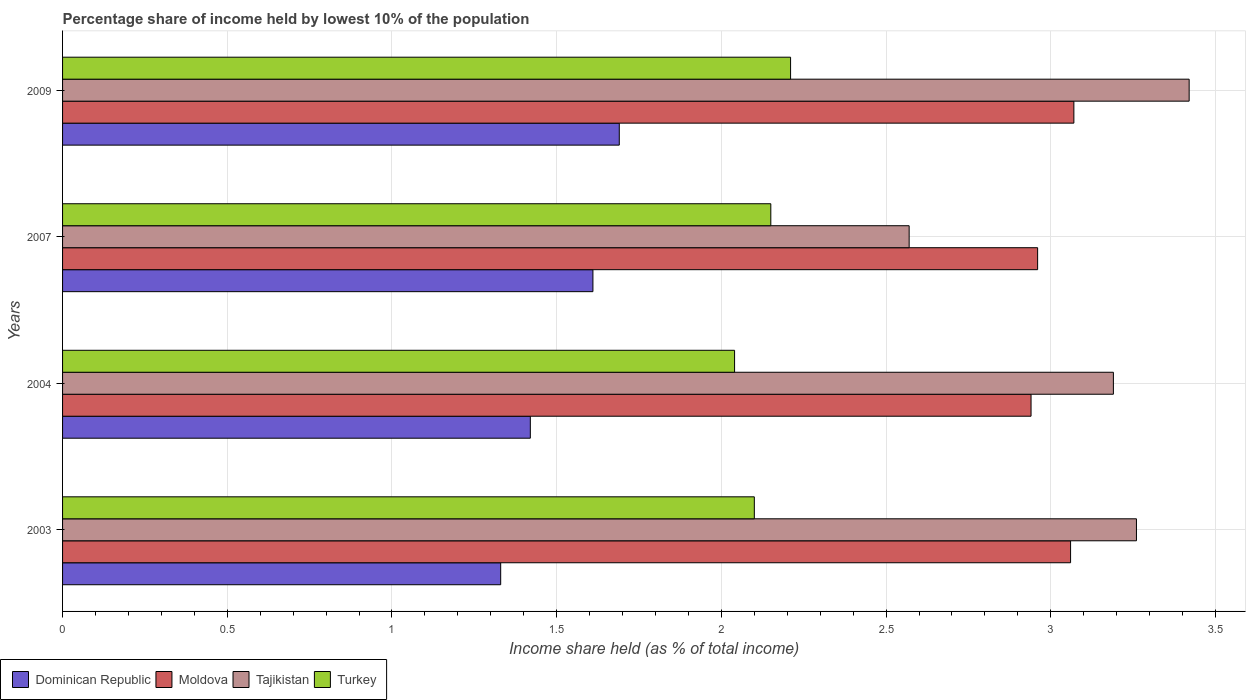Are the number of bars per tick equal to the number of legend labels?
Provide a short and direct response. Yes. How many bars are there on the 1st tick from the bottom?
Ensure brevity in your answer.  4. What is the label of the 2nd group of bars from the top?
Your answer should be compact. 2007. In how many cases, is the number of bars for a given year not equal to the number of legend labels?
Make the answer very short. 0. What is the percentage share of income held by lowest 10% of the population in Turkey in 2009?
Provide a succinct answer. 2.21. Across all years, what is the maximum percentage share of income held by lowest 10% of the population in Tajikistan?
Provide a succinct answer. 3.42. Across all years, what is the minimum percentage share of income held by lowest 10% of the population in Tajikistan?
Keep it short and to the point. 2.57. In which year was the percentage share of income held by lowest 10% of the population in Moldova maximum?
Provide a short and direct response. 2009. In which year was the percentage share of income held by lowest 10% of the population in Dominican Republic minimum?
Provide a succinct answer. 2003. What is the total percentage share of income held by lowest 10% of the population in Dominican Republic in the graph?
Provide a short and direct response. 6.05. What is the difference between the percentage share of income held by lowest 10% of the population in Tajikistan in 2004 and that in 2007?
Your answer should be compact. 0.62. What is the difference between the percentage share of income held by lowest 10% of the population in Moldova in 2009 and the percentage share of income held by lowest 10% of the population in Turkey in 2007?
Make the answer very short. 0.92. What is the average percentage share of income held by lowest 10% of the population in Turkey per year?
Provide a succinct answer. 2.12. In the year 2009, what is the difference between the percentage share of income held by lowest 10% of the population in Moldova and percentage share of income held by lowest 10% of the population in Tajikistan?
Your response must be concise. -0.35. What is the ratio of the percentage share of income held by lowest 10% of the population in Tajikistan in 2004 to that in 2007?
Offer a very short reply. 1.24. Is the percentage share of income held by lowest 10% of the population in Tajikistan in 2003 less than that in 2007?
Your answer should be very brief. No. Is the difference between the percentage share of income held by lowest 10% of the population in Moldova in 2004 and 2009 greater than the difference between the percentage share of income held by lowest 10% of the population in Tajikistan in 2004 and 2009?
Provide a succinct answer. Yes. What is the difference between the highest and the second highest percentage share of income held by lowest 10% of the population in Turkey?
Provide a succinct answer. 0.06. What is the difference between the highest and the lowest percentage share of income held by lowest 10% of the population in Turkey?
Ensure brevity in your answer.  0.17. In how many years, is the percentage share of income held by lowest 10% of the population in Dominican Republic greater than the average percentage share of income held by lowest 10% of the population in Dominican Republic taken over all years?
Your answer should be compact. 2. Is the sum of the percentage share of income held by lowest 10% of the population in Dominican Republic in 2004 and 2007 greater than the maximum percentage share of income held by lowest 10% of the population in Tajikistan across all years?
Make the answer very short. No. Is it the case that in every year, the sum of the percentage share of income held by lowest 10% of the population in Turkey and percentage share of income held by lowest 10% of the population in Moldova is greater than the sum of percentage share of income held by lowest 10% of the population in Dominican Republic and percentage share of income held by lowest 10% of the population in Tajikistan?
Keep it short and to the point. No. What does the 4th bar from the top in 2003 represents?
Offer a terse response. Dominican Republic. What does the 1st bar from the bottom in 2004 represents?
Ensure brevity in your answer.  Dominican Republic. Are all the bars in the graph horizontal?
Your answer should be very brief. Yes. How many years are there in the graph?
Provide a succinct answer. 4. Does the graph contain any zero values?
Your answer should be compact. No. Does the graph contain grids?
Your answer should be very brief. Yes. How are the legend labels stacked?
Your response must be concise. Horizontal. What is the title of the graph?
Make the answer very short. Percentage share of income held by lowest 10% of the population. Does "Ireland" appear as one of the legend labels in the graph?
Make the answer very short. No. What is the label or title of the X-axis?
Make the answer very short. Income share held (as % of total income). What is the Income share held (as % of total income) in Dominican Republic in 2003?
Your response must be concise. 1.33. What is the Income share held (as % of total income) in Moldova in 2003?
Provide a succinct answer. 3.06. What is the Income share held (as % of total income) of Tajikistan in 2003?
Provide a succinct answer. 3.26. What is the Income share held (as % of total income) of Turkey in 2003?
Keep it short and to the point. 2.1. What is the Income share held (as % of total income) of Dominican Republic in 2004?
Make the answer very short. 1.42. What is the Income share held (as % of total income) of Moldova in 2004?
Your response must be concise. 2.94. What is the Income share held (as % of total income) of Tajikistan in 2004?
Keep it short and to the point. 3.19. What is the Income share held (as % of total income) in Turkey in 2004?
Provide a succinct answer. 2.04. What is the Income share held (as % of total income) of Dominican Republic in 2007?
Offer a very short reply. 1.61. What is the Income share held (as % of total income) of Moldova in 2007?
Make the answer very short. 2.96. What is the Income share held (as % of total income) in Tajikistan in 2007?
Offer a terse response. 2.57. What is the Income share held (as % of total income) in Turkey in 2007?
Provide a succinct answer. 2.15. What is the Income share held (as % of total income) of Dominican Republic in 2009?
Offer a terse response. 1.69. What is the Income share held (as % of total income) in Moldova in 2009?
Offer a very short reply. 3.07. What is the Income share held (as % of total income) in Tajikistan in 2009?
Your answer should be very brief. 3.42. What is the Income share held (as % of total income) of Turkey in 2009?
Offer a very short reply. 2.21. Across all years, what is the maximum Income share held (as % of total income) of Dominican Republic?
Offer a terse response. 1.69. Across all years, what is the maximum Income share held (as % of total income) of Moldova?
Give a very brief answer. 3.07. Across all years, what is the maximum Income share held (as % of total income) of Tajikistan?
Your answer should be very brief. 3.42. Across all years, what is the maximum Income share held (as % of total income) in Turkey?
Your answer should be very brief. 2.21. Across all years, what is the minimum Income share held (as % of total income) in Dominican Republic?
Offer a very short reply. 1.33. Across all years, what is the minimum Income share held (as % of total income) of Moldova?
Make the answer very short. 2.94. Across all years, what is the minimum Income share held (as % of total income) in Tajikistan?
Offer a terse response. 2.57. Across all years, what is the minimum Income share held (as % of total income) in Turkey?
Provide a short and direct response. 2.04. What is the total Income share held (as % of total income) in Dominican Republic in the graph?
Provide a succinct answer. 6.05. What is the total Income share held (as % of total income) of Moldova in the graph?
Your answer should be compact. 12.03. What is the total Income share held (as % of total income) of Tajikistan in the graph?
Ensure brevity in your answer.  12.44. What is the difference between the Income share held (as % of total income) of Dominican Republic in 2003 and that in 2004?
Offer a very short reply. -0.09. What is the difference between the Income share held (as % of total income) in Moldova in 2003 and that in 2004?
Your answer should be compact. 0.12. What is the difference between the Income share held (as % of total income) of Tajikistan in 2003 and that in 2004?
Offer a very short reply. 0.07. What is the difference between the Income share held (as % of total income) of Turkey in 2003 and that in 2004?
Give a very brief answer. 0.06. What is the difference between the Income share held (as % of total income) in Dominican Republic in 2003 and that in 2007?
Offer a very short reply. -0.28. What is the difference between the Income share held (as % of total income) of Tajikistan in 2003 and that in 2007?
Your answer should be very brief. 0.69. What is the difference between the Income share held (as % of total income) of Turkey in 2003 and that in 2007?
Provide a short and direct response. -0.05. What is the difference between the Income share held (as % of total income) in Dominican Republic in 2003 and that in 2009?
Your answer should be compact. -0.36. What is the difference between the Income share held (as % of total income) in Moldova in 2003 and that in 2009?
Give a very brief answer. -0.01. What is the difference between the Income share held (as % of total income) of Tajikistan in 2003 and that in 2009?
Keep it short and to the point. -0.16. What is the difference between the Income share held (as % of total income) in Turkey in 2003 and that in 2009?
Your response must be concise. -0.11. What is the difference between the Income share held (as % of total income) of Dominican Republic in 2004 and that in 2007?
Offer a very short reply. -0.19. What is the difference between the Income share held (as % of total income) in Moldova in 2004 and that in 2007?
Make the answer very short. -0.02. What is the difference between the Income share held (as % of total income) of Tajikistan in 2004 and that in 2007?
Your answer should be compact. 0.62. What is the difference between the Income share held (as % of total income) in Turkey in 2004 and that in 2007?
Your answer should be compact. -0.11. What is the difference between the Income share held (as % of total income) in Dominican Republic in 2004 and that in 2009?
Your answer should be very brief. -0.27. What is the difference between the Income share held (as % of total income) of Moldova in 2004 and that in 2009?
Offer a terse response. -0.13. What is the difference between the Income share held (as % of total income) of Tajikistan in 2004 and that in 2009?
Provide a succinct answer. -0.23. What is the difference between the Income share held (as % of total income) in Turkey in 2004 and that in 2009?
Give a very brief answer. -0.17. What is the difference between the Income share held (as % of total income) in Dominican Republic in 2007 and that in 2009?
Keep it short and to the point. -0.08. What is the difference between the Income share held (as % of total income) of Moldova in 2007 and that in 2009?
Provide a succinct answer. -0.11. What is the difference between the Income share held (as % of total income) in Tajikistan in 2007 and that in 2009?
Ensure brevity in your answer.  -0.85. What is the difference between the Income share held (as % of total income) in Turkey in 2007 and that in 2009?
Your answer should be very brief. -0.06. What is the difference between the Income share held (as % of total income) of Dominican Republic in 2003 and the Income share held (as % of total income) of Moldova in 2004?
Provide a succinct answer. -1.61. What is the difference between the Income share held (as % of total income) of Dominican Republic in 2003 and the Income share held (as % of total income) of Tajikistan in 2004?
Your answer should be very brief. -1.86. What is the difference between the Income share held (as % of total income) in Dominican Republic in 2003 and the Income share held (as % of total income) in Turkey in 2004?
Keep it short and to the point. -0.71. What is the difference between the Income share held (as % of total income) in Moldova in 2003 and the Income share held (as % of total income) in Tajikistan in 2004?
Provide a short and direct response. -0.13. What is the difference between the Income share held (as % of total income) of Moldova in 2003 and the Income share held (as % of total income) of Turkey in 2004?
Your answer should be compact. 1.02. What is the difference between the Income share held (as % of total income) in Tajikistan in 2003 and the Income share held (as % of total income) in Turkey in 2004?
Offer a very short reply. 1.22. What is the difference between the Income share held (as % of total income) of Dominican Republic in 2003 and the Income share held (as % of total income) of Moldova in 2007?
Provide a succinct answer. -1.63. What is the difference between the Income share held (as % of total income) in Dominican Republic in 2003 and the Income share held (as % of total income) in Tajikistan in 2007?
Provide a short and direct response. -1.24. What is the difference between the Income share held (as % of total income) in Dominican Republic in 2003 and the Income share held (as % of total income) in Turkey in 2007?
Provide a short and direct response. -0.82. What is the difference between the Income share held (as % of total income) in Moldova in 2003 and the Income share held (as % of total income) in Tajikistan in 2007?
Your answer should be very brief. 0.49. What is the difference between the Income share held (as % of total income) in Moldova in 2003 and the Income share held (as % of total income) in Turkey in 2007?
Your response must be concise. 0.91. What is the difference between the Income share held (as % of total income) in Tajikistan in 2003 and the Income share held (as % of total income) in Turkey in 2007?
Keep it short and to the point. 1.11. What is the difference between the Income share held (as % of total income) of Dominican Republic in 2003 and the Income share held (as % of total income) of Moldova in 2009?
Your answer should be very brief. -1.74. What is the difference between the Income share held (as % of total income) of Dominican Republic in 2003 and the Income share held (as % of total income) of Tajikistan in 2009?
Provide a short and direct response. -2.09. What is the difference between the Income share held (as % of total income) in Dominican Republic in 2003 and the Income share held (as % of total income) in Turkey in 2009?
Provide a short and direct response. -0.88. What is the difference between the Income share held (as % of total income) of Moldova in 2003 and the Income share held (as % of total income) of Tajikistan in 2009?
Keep it short and to the point. -0.36. What is the difference between the Income share held (as % of total income) of Tajikistan in 2003 and the Income share held (as % of total income) of Turkey in 2009?
Your response must be concise. 1.05. What is the difference between the Income share held (as % of total income) of Dominican Republic in 2004 and the Income share held (as % of total income) of Moldova in 2007?
Provide a short and direct response. -1.54. What is the difference between the Income share held (as % of total income) in Dominican Republic in 2004 and the Income share held (as % of total income) in Tajikistan in 2007?
Your response must be concise. -1.15. What is the difference between the Income share held (as % of total income) in Dominican Republic in 2004 and the Income share held (as % of total income) in Turkey in 2007?
Your response must be concise. -0.73. What is the difference between the Income share held (as % of total income) in Moldova in 2004 and the Income share held (as % of total income) in Tajikistan in 2007?
Your response must be concise. 0.37. What is the difference between the Income share held (as % of total income) of Moldova in 2004 and the Income share held (as % of total income) of Turkey in 2007?
Offer a terse response. 0.79. What is the difference between the Income share held (as % of total income) in Dominican Republic in 2004 and the Income share held (as % of total income) in Moldova in 2009?
Your answer should be very brief. -1.65. What is the difference between the Income share held (as % of total income) of Dominican Republic in 2004 and the Income share held (as % of total income) of Turkey in 2009?
Your response must be concise. -0.79. What is the difference between the Income share held (as % of total income) of Moldova in 2004 and the Income share held (as % of total income) of Tajikistan in 2009?
Offer a terse response. -0.48. What is the difference between the Income share held (as % of total income) of Moldova in 2004 and the Income share held (as % of total income) of Turkey in 2009?
Give a very brief answer. 0.73. What is the difference between the Income share held (as % of total income) in Dominican Republic in 2007 and the Income share held (as % of total income) in Moldova in 2009?
Your answer should be compact. -1.46. What is the difference between the Income share held (as % of total income) of Dominican Republic in 2007 and the Income share held (as % of total income) of Tajikistan in 2009?
Your answer should be very brief. -1.81. What is the difference between the Income share held (as % of total income) in Moldova in 2007 and the Income share held (as % of total income) in Tajikistan in 2009?
Make the answer very short. -0.46. What is the difference between the Income share held (as % of total income) of Moldova in 2007 and the Income share held (as % of total income) of Turkey in 2009?
Ensure brevity in your answer.  0.75. What is the difference between the Income share held (as % of total income) in Tajikistan in 2007 and the Income share held (as % of total income) in Turkey in 2009?
Make the answer very short. 0.36. What is the average Income share held (as % of total income) in Dominican Republic per year?
Provide a succinct answer. 1.51. What is the average Income share held (as % of total income) in Moldova per year?
Provide a succinct answer. 3.01. What is the average Income share held (as % of total income) in Tajikistan per year?
Ensure brevity in your answer.  3.11. What is the average Income share held (as % of total income) of Turkey per year?
Offer a very short reply. 2.12. In the year 2003, what is the difference between the Income share held (as % of total income) in Dominican Republic and Income share held (as % of total income) in Moldova?
Your answer should be very brief. -1.73. In the year 2003, what is the difference between the Income share held (as % of total income) in Dominican Republic and Income share held (as % of total income) in Tajikistan?
Give a very brief answer. -1.93. In the year 2003, what is the difference between the Income share held (as % of total income) of Dominican Republic and Income share held (as % of total income) of Turkey?
Offer a very short reply. -0.77. In the year 2003, what is the difference between the Income share held (as % of total income) of Moldova and Income share held (as % of total income) of Tajikistan?
Provide a short and direct response. -0.2. In the year 2003, what is the difference between the Income share held (as % of total income) of Tajikistan and Income share held (as % of total income) of Turkey?
Make the answer very short. 1.16. In the year 2004, what is the difference between the Income share held (as % of total income) of Dominican Republic and Income share held (as % of total income) of Moldova?
Keep it short and to the point. -1.52. In the year 2004, what is the difference between the Income share held (as % of total income) of Dominican Republic and Income share held (as % of total income) of Tajikistan?
Provide a short and direct response. -1.77. In the year 2004, what is the difference between the Income share held (as % of total income) in Dominican Republic and Income share held (as % of total income) in Turkey?
Keep it short and to the point. -0.62. In the year 2004, what is the difference between the Income share held (as % of total income) of Moldova and Income share held (as % of total income) of Tajikistan?
Give a very brief answer. -0.25. In the year 2004, what is the difference between the Income share held (as % of total income) in Moldova and Income share held (as % of total income) in Turkey?
Offer a very short reply. 0.9. In the year 2004, what is the difference between the Income share held (as % of total income) of Tajikistan and Income share held (as % of total income) of Turkey?
Your answer should be compact. 1.15. In the year 2007, what is the difference between the Income share held (as % of total income) of Dominican Republic and Income share held (as % of total income) of Moldova?
Ensure brevity in your answer.  -1.35. In the year 2007, what is the difference between the Income share held (as % of total income) in Dominican Republic and Income share held (as % of total income) in Tajikistan?
Your answer should be very brief. -0.96. In the year 2007, what is the difference between the Income share held (as % of total income) in Dominican Republic and Income share held (as % of total income) in Turkey?
Ensure brevity in your answer.  -0.54. In the year 2007, what is the difference between the Income share held (as % of total income) of Moldova and Income share held (as % of total income) of Tajikistan?
Provide a succinct answer. 0.39. In the year 2007, what is the difference between the Income share held (as % of total income) in Moldova and Income share held (as % of total income) in Turkey?
Give a very brief answer. 0.81. In the year 2007, what is the difference between the Income share held (as % of total income) of Tajikistan and Income share held (as % of total income) of Turkey?
Make the answer very short. 0.42. In the year 2009, what is the difference between the Income share held (as % of total income) of Dominican Republic and Income share held (as % of total income) of Moldova?
Give a very brief answer. -1.38. In the year 2009, what is the difference between the Income share held (as % of total income) of Dominican Republic and Income share held (as % of total income) of Tajikistan?
Offer a terse response. -1.73. In the year 2009, what is the difference between the Income share held (as % of total income) in Dominican Republic and Income share held (as % of total income) in Turkey?
Provide a short and direct response. -0.52. In the year 2009, what is the difference between the Income share held (as % of total income) of Moldova and Income share held (as % of total income) of Tajikistan?
Ensure brevity in your answer.  -0.35. In the year 2009, what is the difference between the Income share held (as % of total income) in Moldova and Income share held (as % of total income) in Turkey?
Your response must be concise. 0.86. In the year 2009, what is the difference between the Income share held (as % of total income) in Tajikistan and Income share held (as % of total income) in Turkey?
Your answer should be compact. 1.21. What is the ratio of the Income share held (as % of total income) in Dominican Republic in 2003 to that in 2004?
Give a very brief answer. 0.94. What is the ratio of the Income share held (as % of total income) in Moldova in 2003 to that in 2004?
Ensure brevity in your answer.  1.04. What is the ratio of the Income share held (as % of total income) of Tajikistan in 2003 to that in 2004?
Provide a short and direct response. 1.02. What is the ratio of the Income share held (as % of total income) in Turkey in 2003 to that in 2004?
Offer a terse response. 1.03. What is the ratio of the Income share held (as % of total income) in Dominican Republic in 2003 to that in 2007?
Offer a terse response. 0.83. What is the ratio of the Income share held (as % of total income) in Moldova in 2003 to that in 2007?
Ensure brevity in your answer.  1.03. What is the ratio of the Income share held (as % of total income) in Tajikistan in 2003 to that in 2007?
Provide a short and direct response. 1.27. What is the ratio of the Income share held (as % of total income) in Turkey in 2003 to that in 2007?
Offer a very short reply. 0.98. What is the ratio of the Income share held (as % of total income) in Dominican Republic in 2003 to that in 2009?
Provide a short and direct response. 0.79. What is the ratio of the Income share held (as % of total income) in Moldova in 2003 to that in 2009?
Your answer should be compact. 1. What is the ratio of the Income share held (as % of total income) of Tajikistan in 2003 to that in 2009?
Give a very brief answer. 0.95. What is the ratio of the Income share held (as % of total income) of Turkey in 2003 to that in 2009?
Your response must be concise. 0.95. What is the ratio of the Income share held (as % of total income) of Dominican Republic in 2004 to that in 2007?
Your answer should be very brief. 0.88. What is the ratio of the Income share held (as % of total income) of Moldova in 2004 to that in 2007?
Keep it short and to the point. 0.99. What is the ratio of the Income share held (as % of total income) in Tajikistan in 2004 to that in 2007?
Your answer should be very brief. 1.24. What is the ratio of the Income share held (as % of total income) of Turkey in 2004 to that in 2007?
Offer a terse response. 0.95. What is the ratio of the Income share held (as % of total income) of Dominican Republic in 2004 to that in 2009?
Offer a terse response. 0.84. What is the ratio of the Income share held (as % of total income) in Moldova in 2004 to that in 2009?
Give a very brief answer. 0.96. What is the ratio of the Income share held (as % of total income) in Tajikistan in 2004 to that in 2009?
Give a very brief answer. 0.93. What is the ratio of the Income share held (as % of total income) of Dominican Republic in 2007 to that in 2009?
Keep it short and to the point. 0.95. What is the ratio of the Income share held (as % of total income) of Moldova in 2007 to that in 2009?
Make the answer very short. 0.96. What is the ratio of the Income share held (as % of total income) in Tajikistan in 2007 to that in 2009?
Your answer should be very brief. 0.75. What is the ratio of the Income share held (as % of total income) in Turkey in 2007 to that in 2009?
Your response must be concise. 0.97. What is the difference between the highest and the second highest Income share held (as % of total income) of Dominican Republic?
Offer a very short reply. 0.08. What is the difference between the highest and the second highest Income share held (as % of total income) of Moldova?
Offer a terse response. 0.01. What is the difference between the highest and the second highest Income share held (as % of total income) of Tajikistan?
Provide a succinct answer. 0.16. What is the difference between the highest and the lowest Income share held (as % of total income) of Dominican Republic?
Provide a short and direct response. 0.36. What is the difference between the highest and the lowest Income share held (as % of total income) in Moldova?
Your answer should be compact. 0.13. What is the difference between the highest and the lowest Income share held (as % of total income) in Tajikistan?
Offer a terse response. 0.85. What is the difference between the highest and the lowest Income share held (as % of total income) of Turkey?
Your response must be concise. 0.17. 